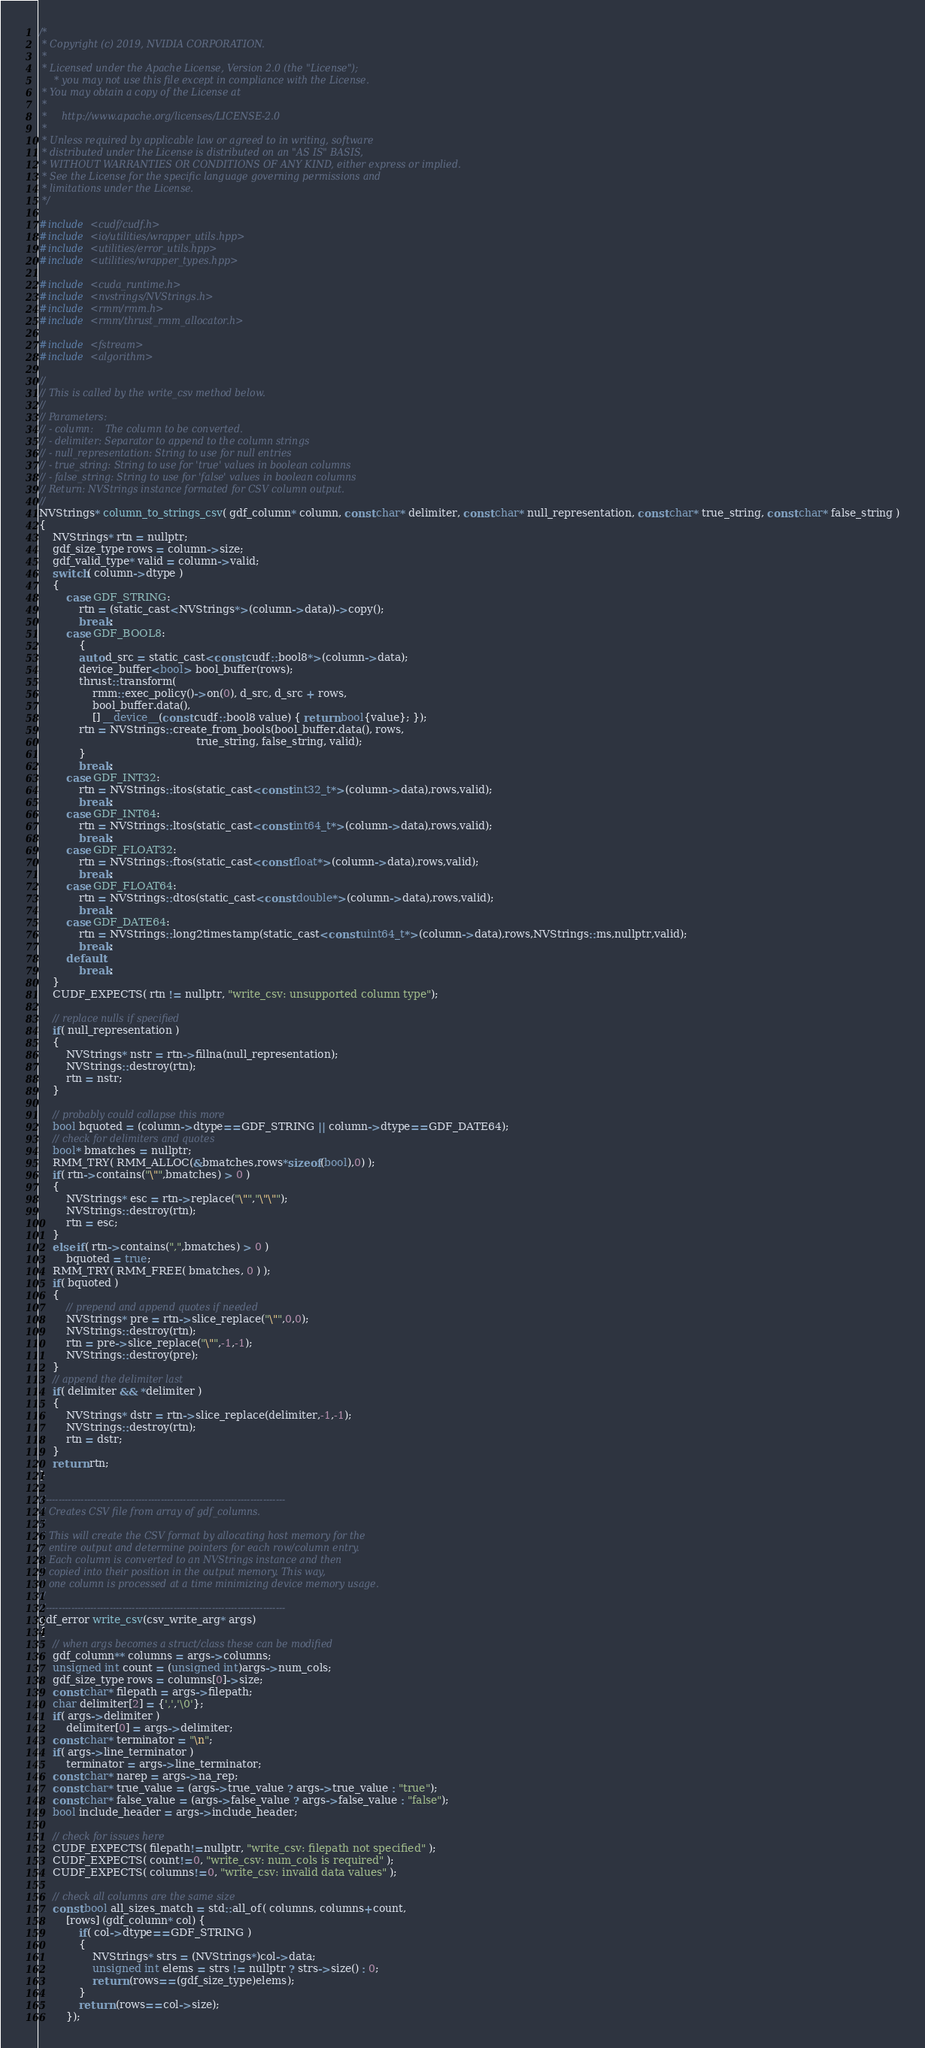<code> <loc_0><loc_0><loc_500><loc_500><_Cuda_>/*
 * Copyright (c) 2019, NVIDIA CORPORATION.
 *
 * Licensed under the Apache License, Version 2.0 (the "License");
     * you may not use this file except in compliance with the License.
 * You may obtain a copy of the License at
 *
 *     http://www.apache.org/licenses/LICENSE-2.0
 *
 * Unless required by applicable law or agreed to in writing, software
 * distributed under the License is distributed on an "AS IS" BASIS,
 * WITHOUT WARRANTIES OR CONDITIONS OF ANY KIND, either express or implied.
 * See the License for the specific language governing permissions and
 * limitations under the License.
 */

#include <cudf/cudf.h>
#include <io/utilities/wrapper_utils.hpp>
#include <utilities/error_utils.hpp>
#include <utilities/wrapper_types.hpp>

#include <cuda_runtime.h>
#include <nvstrings/NVStrings.h>
#include <rmm/rmm.h>
#include <rmm/thrust_rmm_allocator.h>

#include <fstream>
#include <algorithm>

//
// This is called by the write_csv method below.
//
// Parameters:
// - column:    The column to be converted.
// - delimiter: Separator to append to the column strings
// - null_representation: String to use for null entries
// - true_string: String to use for 'true' values in boolean columns
// - false_string: String to use for 'false' values in boolean columns
// Return: NVStrings instance formated for CSV column output.
//
NVStrings* column_to_strings_csv( gdf_column* column, const char* delimiter, const char* null_representation, const char* true_string, const char* false_string )
{
    NVStrings* rtn = nullptr;
    gdf_size_type rows = column->size;
    gdf_valid_type* valid = column->valid;
    switch( column->dtype )
    {
        case GDF_STRING:
            rtn = (static_cast<NVStrings*>(column->data))->copy();
            break;
        case GDF_BOOL8:
            {
            auto d_src = static_cast<const cudf::bool8*>(column->data);
            device_buffer<bool> bool_buffer(rows);
            thrust::transform(
                rmm::exec_policy()->on(0), d_src, d_src + rows,
                bool_buffer.data(),
                [] __device__(const cudf::bool8 value) { return bool{value}; });
            rtn = NVStrings::create_from_bools(bool_buffer.data(), rows,
                                               true_string, false_string, valid);
            }
            break;
        case GDF_INT32:
            rtn = NVStrings::itos(static_cast<const int32_t*>(column->data),rows,valid);
            break;
        case GDF_INT64:
            rtn = NVStrings::ltos(static_cast<const int64_t*>(column->data),rows,valid);
            break;
        case GDF_FLOAT32:
            rtn = NVStrings::ftos(static_cast<const float*>(column->data),rows,valid);
            break;
        case GDF_FLOAT64:
            rtn = NVStrings::dtos(static_cast<const double*>(column->data),rows,valid);
            break;
        case GDF_DATE64:
            rtn = NVStrings::long2timestamp(static_cast<const uint64_t*>(column->data),rows,NVStrings::ms,nullptr,valid);
            break;
        default:
            break;
    }
    CUDF_EXPECTS( rtn != nullptr, "write_csv: unsupported column type");

    // replace nulls if specified
    if( null_representation )
    {
        NVStrings* nstr = rtn->fillna(null_representation);
        NVStrings::destroy(rtn);
        rtn = nstr;
    }

    // probably could collapse this more
    bool bquoted = (column->dtype==GDF_STRING || column->dtype==GDF_DATE64);
    // check for delimiters and quotes
    bool* bmatches = nullptr;
    RMM_TRY( RMM_ALLOC(&bmatches,rows*sizeof(bool),0) );
    if( rtn->contains("\"",bmatches) > 0 )
    {
        NVStrings* esc = rtn->replace("\"","\"\"");
        NVStrings::destroy(rtn);
        rtn = esc;
    }
    else if( rtn->contains(",",bmatches) > 0 )
        bquoted = true;
    RMM_TRY( RMM_FREE( bmatches, 0 ) );
    if( bquoted )
    {
        // prepend and append quotes if needed
        NVStrings* pre = rtn->slice_replace("\"",0,0);
        NVStrings::destroy(rtn);
        rtn = pre->slice_replace("\"",-1,-1);
        NVStrings::destroy(pre);
    }
    // append the delimiter last
    if( delimiter && *delimiter )
    {
        NVStrings* dstr = rtn->slice_replace(delimiter,-1,-1);
        NVStrings::destroy(rtn);
        rtn = dstr;
    }
    return rtn;
}

//---------------------------------------------------------------------------
// Creates CSV file from array of gdf_columns.
//
// This will create the CSV format by allocating host memory for the
// entire output and determine pointers for each row/column entry.
// Each column is converted to an NVStrings instance and then
// copied into their position in the output memory. This way,
// one column is processed at a time minimizing device memory usage.
//
//---------------------------------------------------------------------------
gdf_error write_csv(csv_write_arg* args)
{
    // when args becomes a struct/class these can be modified
    gdf_column** columns = args->columns;
    unsigned int count = (unsigned int)args->num_cols;
    gdf_size_type rows = columns[0]->size;
    const char* filepath = args->filepath;
    char delimiter[2] = {',','\0'};
    if( args->delimiter )
        delimiter[0] = args->delimiter;
    const char* terminator = "\n";
    if( args->line_terminator )
        terminator = args->line_terminator;
    const char* narep = args->na_rep;
    const char* true_value = (args->true_value ? args->true_value : "true");
    const char* false_value = (args->false_value ? args->false_value : "false");
    bool include_header = args->include_header;

    // check for issues here
    CUDF_EXPECTS( filepath!=nullptr, "write_csv: filepath not specified" );
    CUDF_EXPECTS( count!=0, "write_csv: num_cols is required" );
    CUDF_EXPECTS( columns!=0, "write_csv: invalid data values" );

    // check all columns are the same size
    const bool all_sizes_match = std::all_of( columns, columns+count,
        [rows] (gdf_column* col) {
            if( col->dtype==GDF_STRING )
            {
                NVStrings* strs = (NVStrings*)col->data;
                unsigned int elems = strs != nullptr ? strs->size() : 0;
                return (rows==(gdf_size_type)elems);
            }
            return (rows==col->size);
        });</code> 